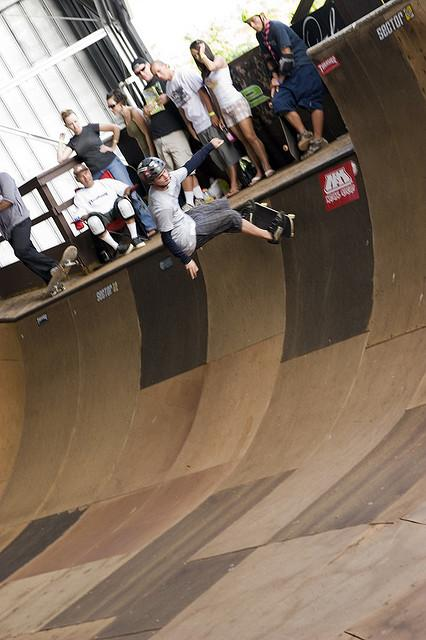What is the man skateboarding on? skateboard 